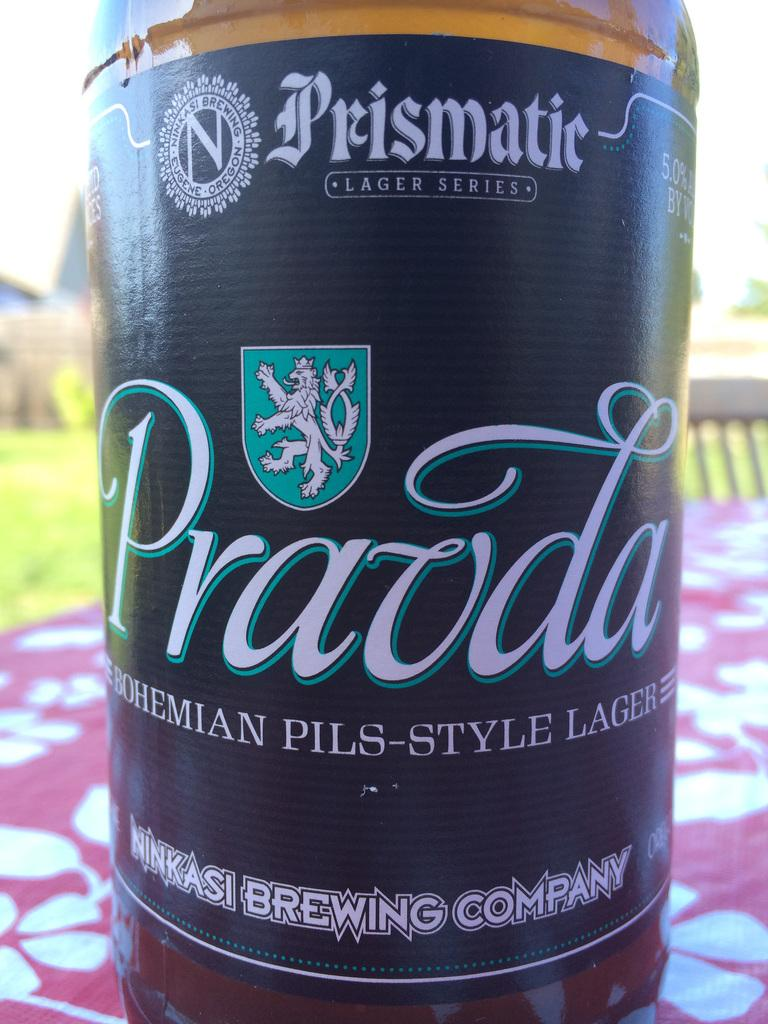<image>
Share a concise interpretation of the image provided. A beer is on an outdoor table and says Pravda Bohemian Pils-Style Lager. 